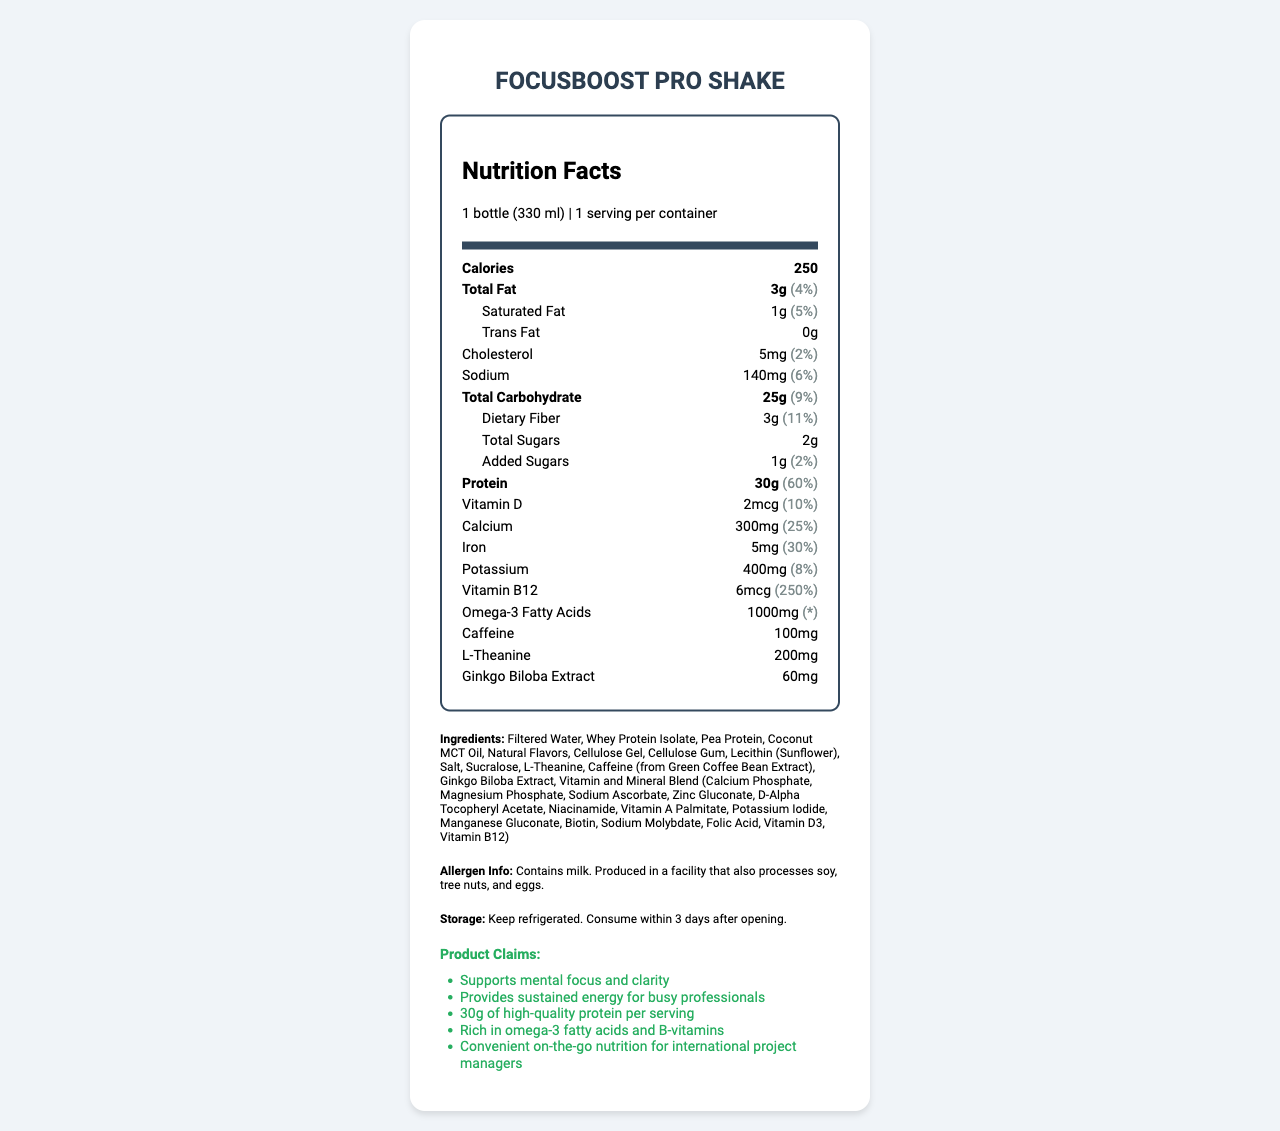what is the serving size of FocusBoost Pro Shake? The serving size information is explicitly stated near the top of the document under the "Nutrition Facts" header.
Answer: 1 bottle (330 ml) How many calories are in one serving of the protein shake? The document lists the calorie content right below the serving size information as "Calories: 250".
Answer: 250 What ingredient is listed first in the ingredient list? The ingredients are listed in the order of predominance by weight, and "Filtered Water" is the first item in the list mentioned under the “Ingredients” section.
Answer: Filtered Water How much protein does one serving contain? The document states that there are 30 grams of protein per serving, under the protein section in the nutrition facts.
Answer: 30g What is the daily value percentage of Vitamin B12 in one serving? The document lists the daily value for Vitamin B12 as 250%, shown beneath the protein information.
Answer: 250% What are the claims made by the product? These claims are found under the “Product Claims” section.
Answer: Supports mental focus and clarity, Provides sustained energy for busy professionals, 30g of high-quality protein per serving, Rich in omega-3 fatty acids and B-vitamins, Convenient on-the-go nutrition for international project managers What is the amount of caffeine in each serving? The amount of caffeine is listed under the section of various specific ingredients in the nutrition facts, "Caffeine: 100mg."
Answer: 100mg Which nutrient has the highest daily value percentage? A. Calcium B. Protein C. Iron D. Vitamin B12 Vitamin B12 has the highest daily value percentage at 250%, as listed under its respective nutrient information.
Answer: D Which of the following allergens is present in the FocusBoost Pro Shake? I. Soy II. Milk III. Eggs IV. Tree Nuts The allergen information section clearly states "Contains milk" and mentions production in a facility that processes soy, tree nuts, and eggs, but the shake itself specifically contains milk.
Answer: II Does the product contain any trans fat? The nutrition facts explicitly list "Trans Fat: 0g" under the fat content section.
Answer: No Summarize the main idea of the document. The document contains detailed information about the nutritional content, ingredients, allergen warnings, and other relevant claims that emphasize the product's benefits for mental clarity and overall nutrition.
Answer: The document describes the nutrition facts, key ingredients, allergen information, and claims of the FocusBoost Pro Shake, a protein shake designed for busy professionals. It highlights its high protein content, essential nutrients for mental focus, and convenient on-the-go packaging. Does the shake contain any sugar? The document lists "Total Sugars: 2g" and "Added Sugars: 1g" under the carbohydrate section.
Answer: Yes What is the daily value percentage of Omega-3 Fatty Acids? The document lists the amount of Omega-3 Fatty Acids as "1000mg" but does not provide a daily value percentage for this nutrient, indicated by "*".
Answer: Not provided Which vitamins and minerals are included in the Vitamin and Mineral Blend? The Vitamin and Mineral Blend section under the ingredients list specifies these vitamins and minerals.
Answer: Calcium Phosphate, Magnesium Phosphate, Sodium Ascorbate, Zinc Gluconate, D-Alpha Tocopheryl Acetate, Niacinamide, Vitamin A Palmitate, Potassium Iodide, Manganese Gluconate, Biotin, Sodium Molybdate, Folic Acid, Vitamin D3, Vitamin B12 